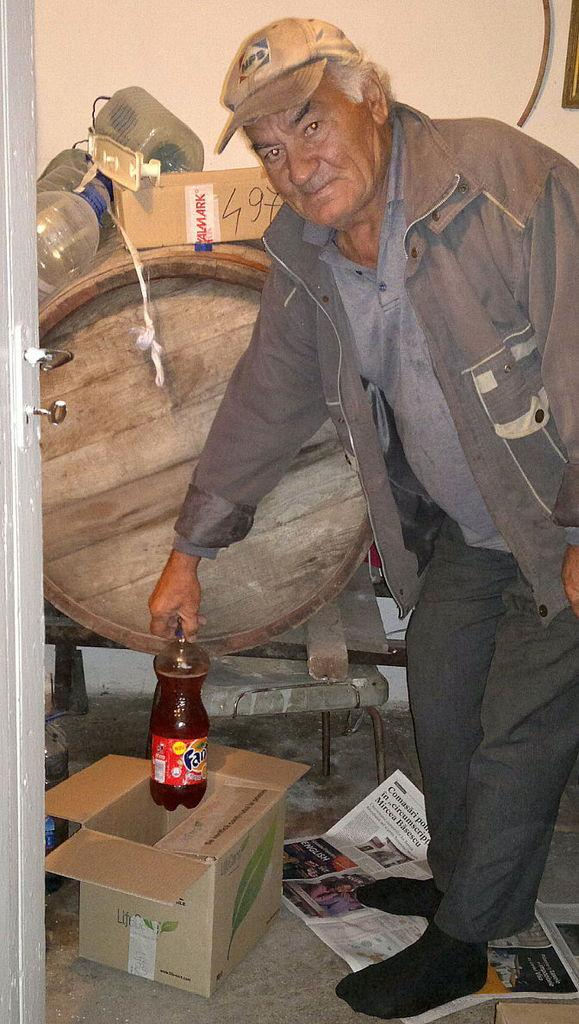What is the main subject of the image? The main subject of the image is a man. What is the man doing in the image? The man is standing in the image. What object is the man holding in his hand? The man is holding a bottle in his hand. What type of border is visible around the man in the image? There is no border visible around the man in the image. Can you tell me who the parent of the man is in the image? There is no information about the man's parent in the image. 